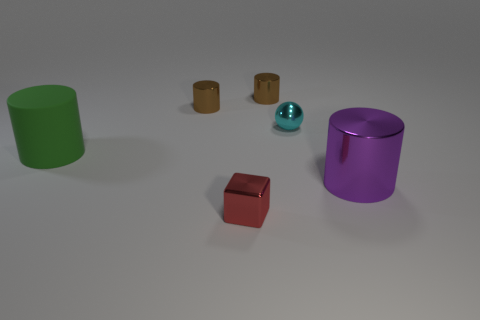How do the sizes of the green and purple objects compare? The purple object is taller and appears to have a larger diameter than the green one, making it the largest object in the group by both height and volume. Could the small brown objects fit inside the green tube? Yes, considering the diameter of the green tube and the smaller size of the brown objects, it seems plausible that the brown objects could fit inside the green tube. 